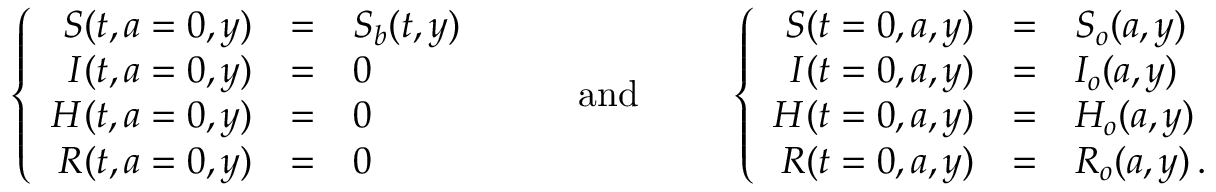Convert formula to latex. <formula><loc_0><loc_0><loc_500><loc_500>\left \{ \begin{array} { r c l } { S ( t , a = 0 , y ) } & { = } & { S _ { b } ( t , y ) } \\ { I ( t , a = 0 , y ) } & { = } & { 0 } \\ { H ( t , a = 0 , y ) } & { = } & { 0 } \\ { R ( t , a = 0 , y ) } & { = } & { 0 } \end{array} \quad a n d \quad \left \{ \begin{array} { r c l } { S ( t = 0 , a , y ) } & { = } & { S _ { o } ( a , y ) } \\ { I ( t = 0 , a , y ) } & { = } & { I _ { o } ( a , y ) } \\ { H ( t = 0 , a , y ) } & { = } & { H _ { o } ( a , y ) } \\ { R ( t = 0 , a , y ) } & { = } & { R _ { o } ( a , y ) \, . } \end{array}</formula> 